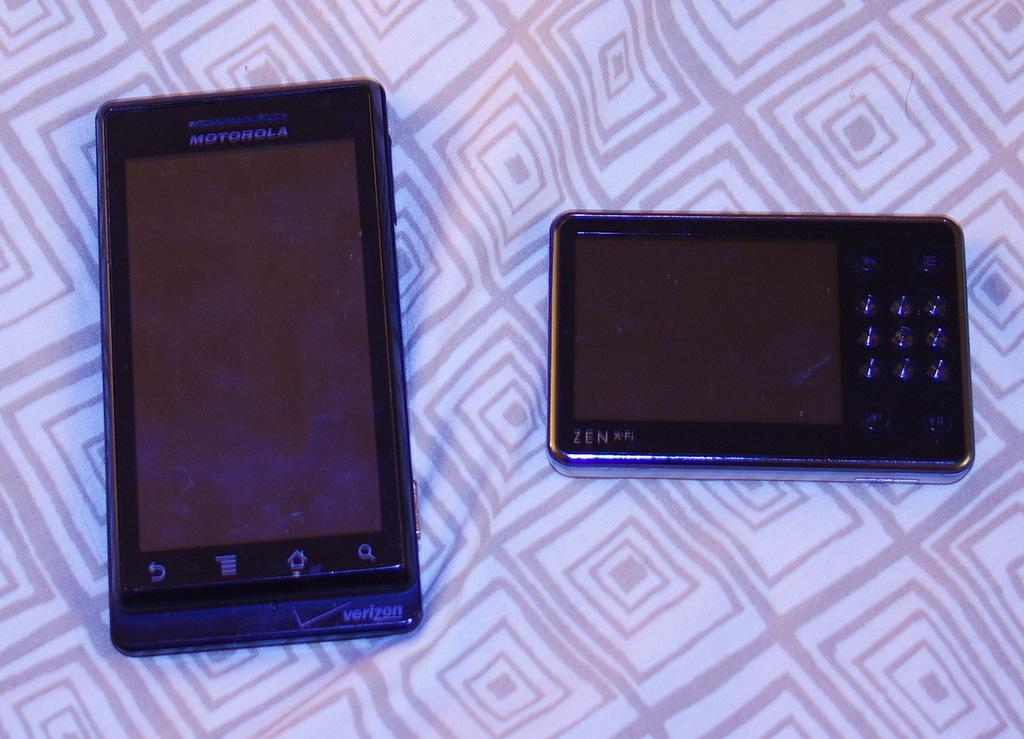<image>
Relay a brief, clear account of the picture shown. A Motorola phone and a Zen phone on a piece of fabric, one phone says Verizon. 